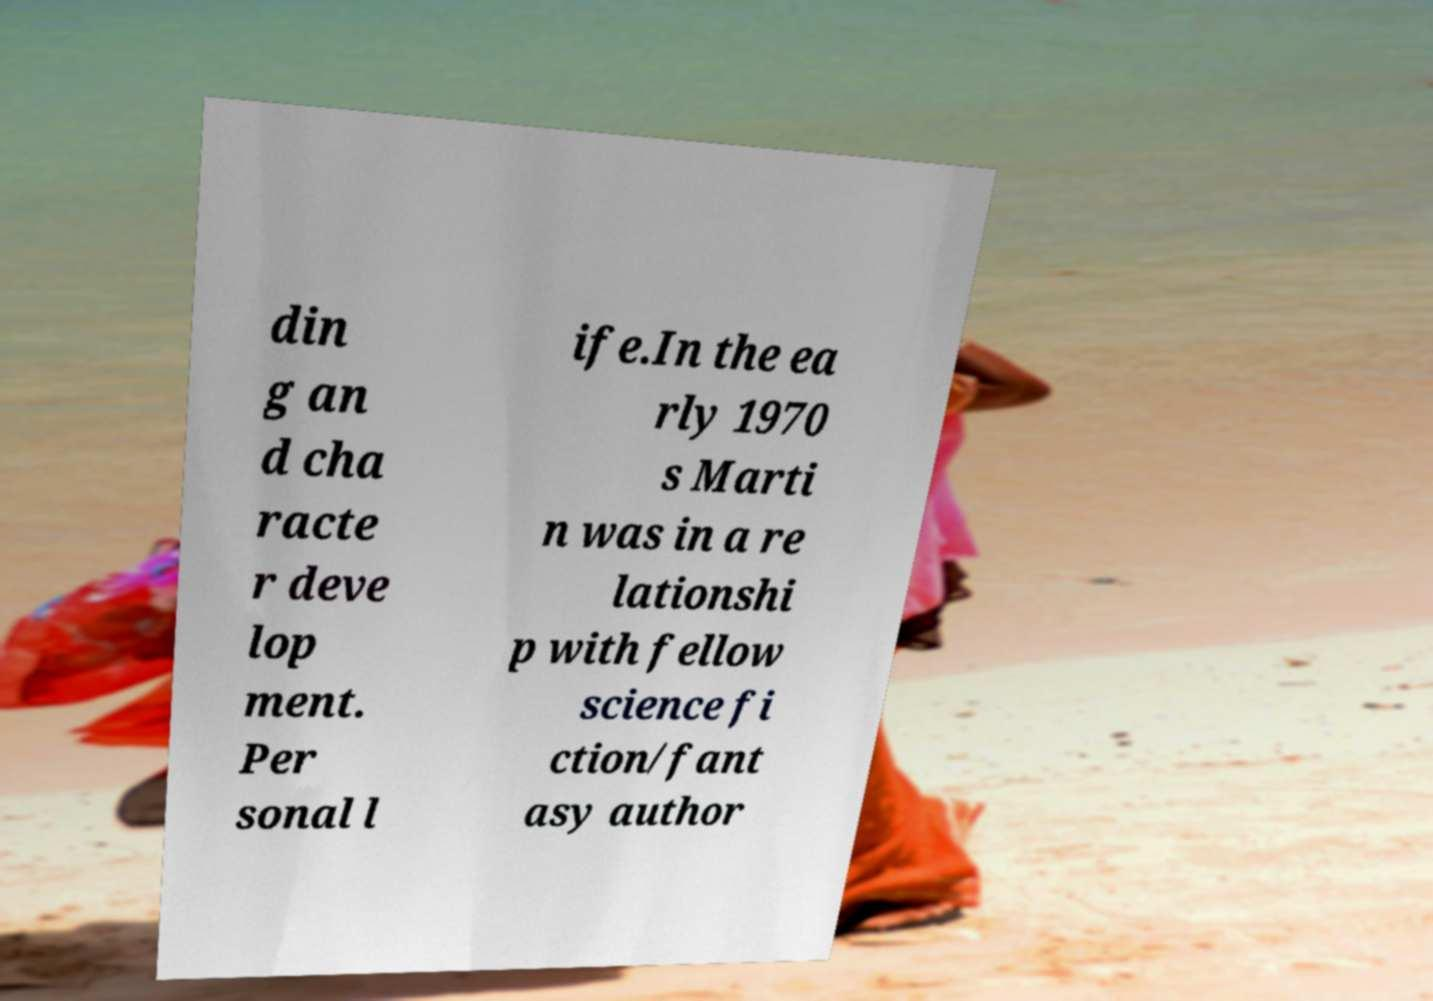I need the written content from this picture converted into text. Can you do that? din g an d cha racte r deve lop ment. Per sonal l ife.In the ea rly 1970 s Marti n was in a re lationshi p with fellow science fi ction/fant asy author 